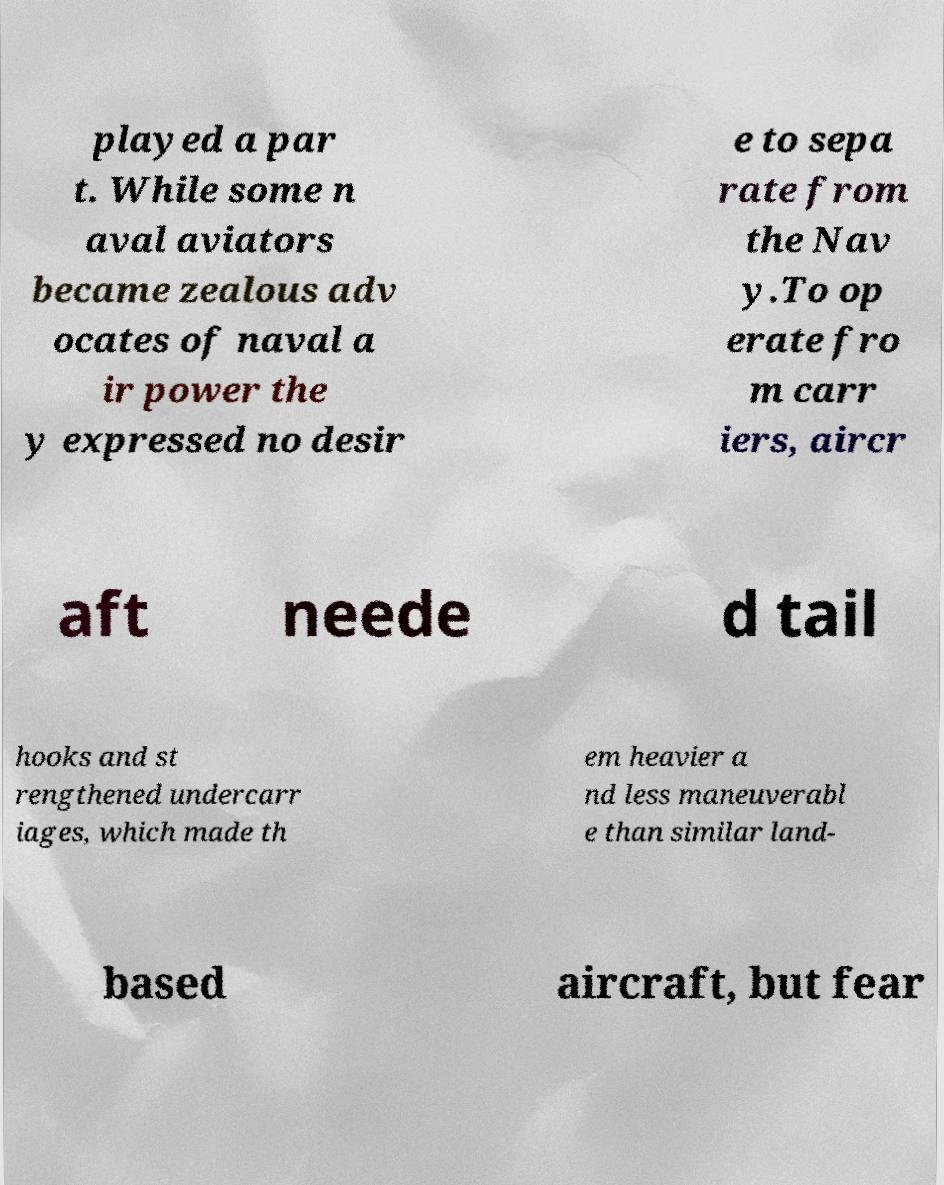Can you read and provide the text displayed in the image?This photo seems to have some interesting text. Can you extract and type it out for me? played a par t. While some n aval aviators became zealous adv ocates of naval a ir power the y expressed no desir e to sepa rate from the Nav y.To op erate fro m carr iers, aircr aft neede d tail hooks and st rengthened undercarr iages, which made th em heavier a nd less maneuverabl e than similar land- based aircraft, but fear 